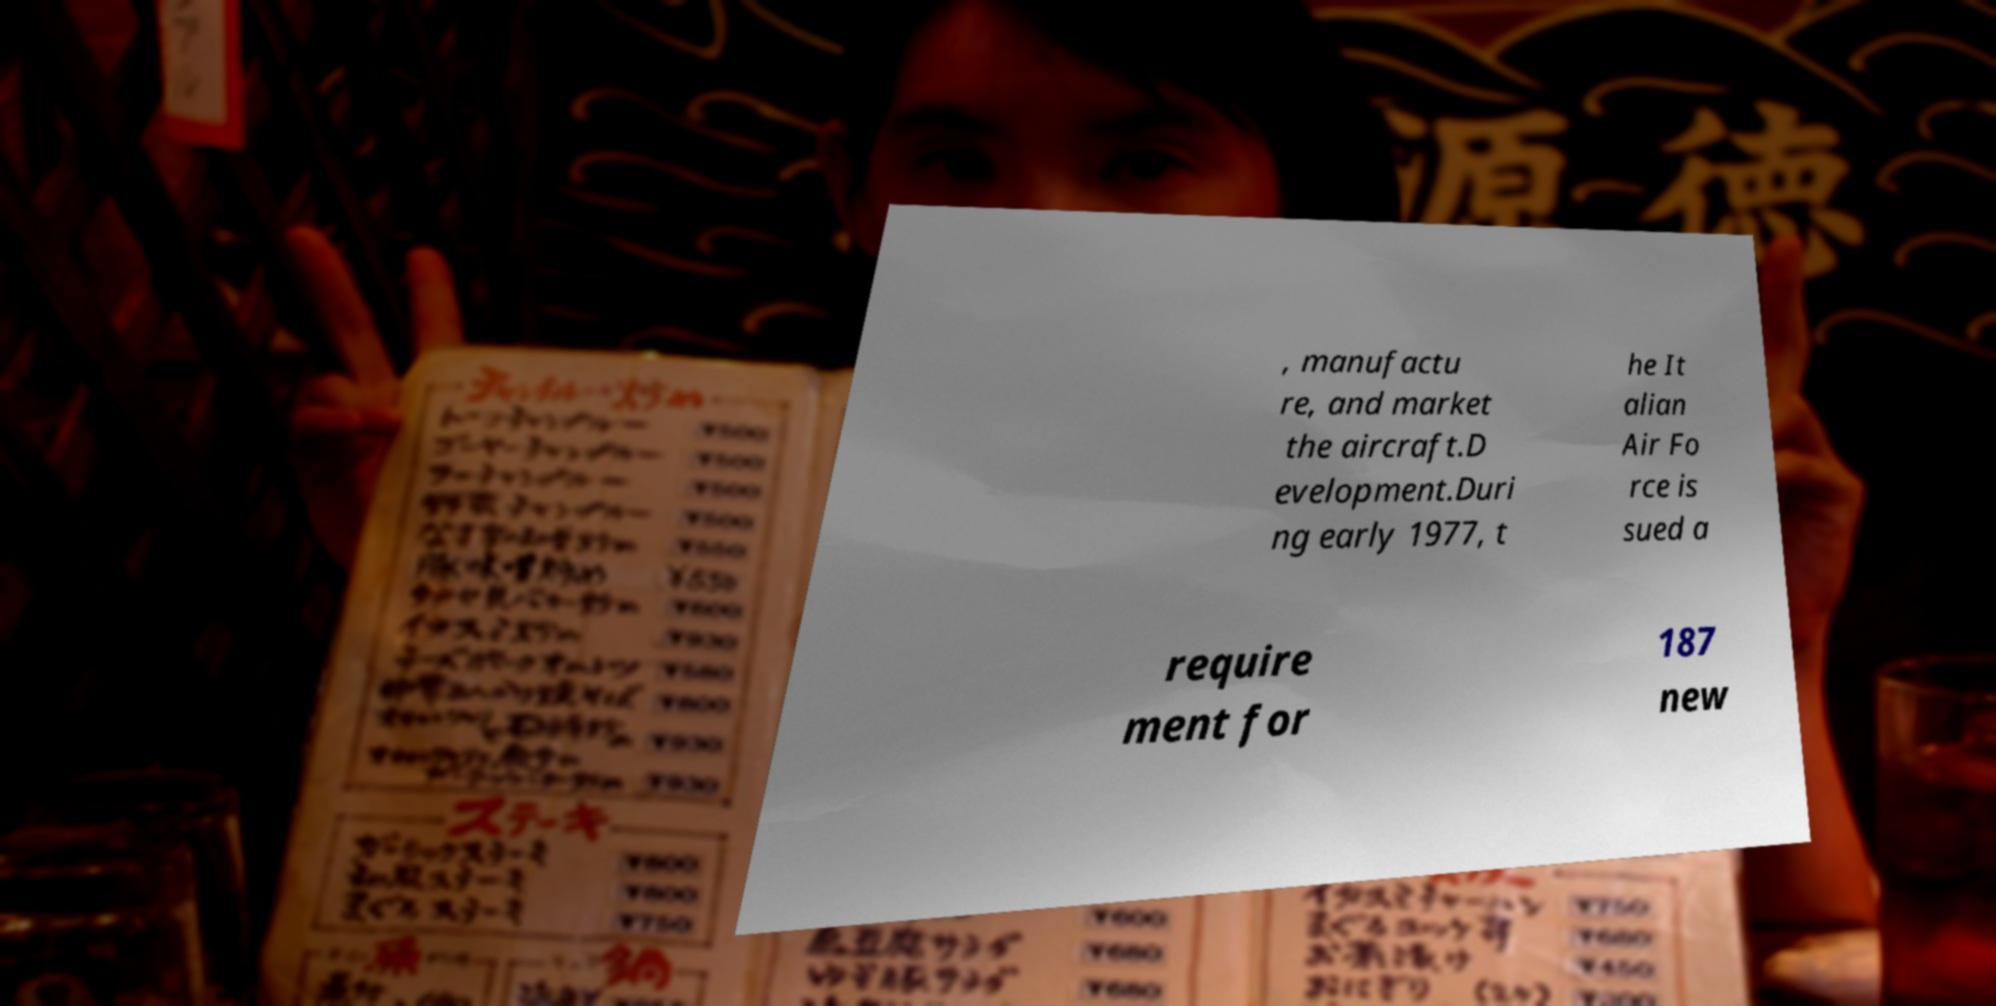Could you extract and type out the text from this image? , manufactu re, and market the aircraft.D evelopment.Duri ng early 1977, t he It alian Air Fo rce is sued a require ment for 187 new 